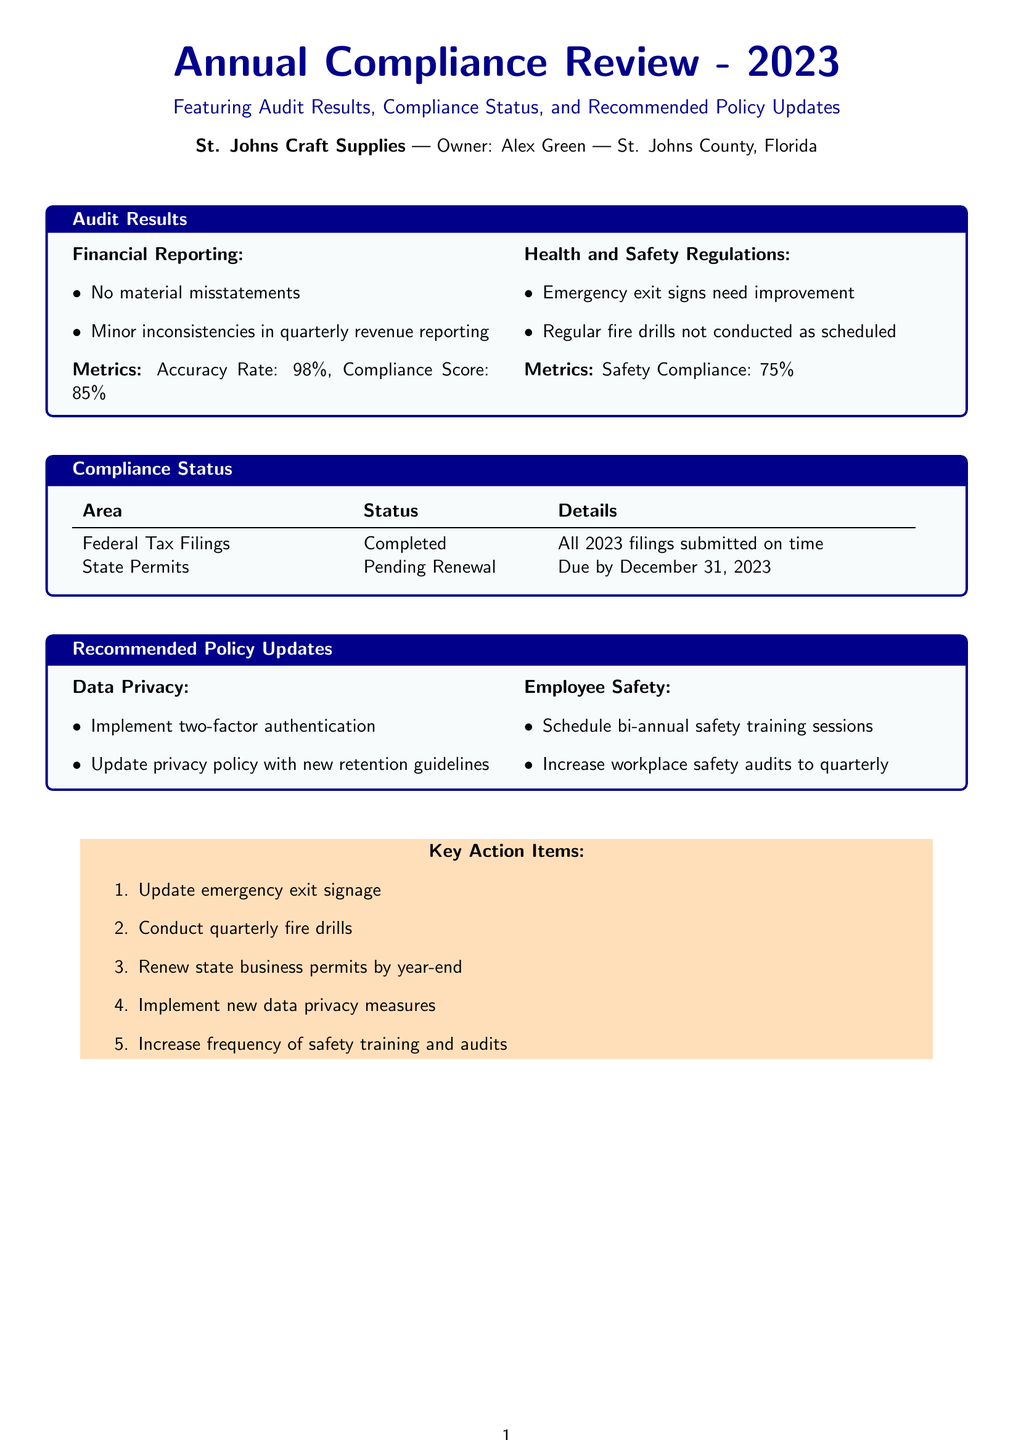What is the compliance score for financial reporting? The compliance score for financial reporting is calculated based on the audit results section, which indicates a compliance score of 85%.
Answer: 85% What is the safety compliance percentage? The safety compliance percentage is specified in the health and safety regulations section of the audit results, which states it is 75%.
Answer: 75% What is the status of the state permits? The compliance status table indicates that state permits are pending renewal.
Answer: Pending Renewal What is one of the recommendations for employee safety? The recommended policy updates section lists various actions, including scheduling bi-annual safety training sessions.
Answer: Schedule bi-annual safety training sessions When are the federal tax filings due? The compliance status section indicates that all 2023 federal tax filings have been completed and submitted on time, implying they are due at various points throughout the year, but no specific date is mentioned.
Answer: Completed What is the accuracy rate for financial reporting? The audit results specify that the accuracy rate for financial reporting is 98%.
Answer: 98% How many key action items are listed? The key action items section contains an enumerated list of items, which totals five action items.
Answer: 5 What improvement is needed for emergency exit signs? The audit results highlight that emergency exit signs need improvement.
Answer: Improvement What are the improvements recommended in data privacy? The recommended policy updates for data privacy include implementing two-factor authentication and updating the privacy policy with new retention guidelines.
Answer: Two-factor authentication and update privacy policy 